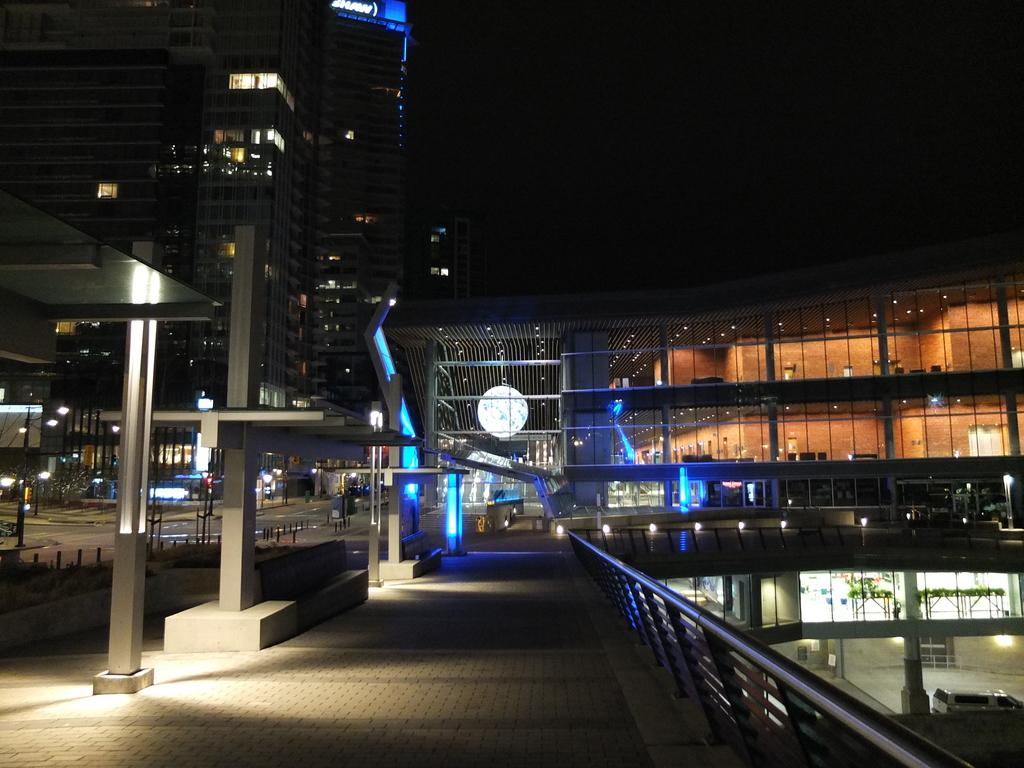What type of structures can be seen in the image? There are buildings in the image. What can be observed illuminating the scene in the image? There are lights in the image. What architectural elements are present in the image? There are pillars in the image. How would you describe the overall lighting in the image? The background of the image appears dark. How many brothers are depicted in the image? There are no people, including brothers, present in the image. What type of twig can be seen growing on the pillars in the image? There are no plants or twigs present on the pillars in the image. 